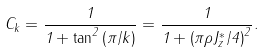Convert formula to latex. <formula><loc_0><loc_0><loc_500><loc_500>C _ { k } = \frac { 1 } { 1 + \tan ^ { 2 } \left ( \pi / k \right ) } = \frac { 1 } { 1 + \left ( \pi \rho J _ { z } ^ { \ast } / 4 \right ) ^ { 2 } } .</formula> 